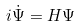<formula> <loc_0><loc_0><loc_500><loc_500>i \dot { \Psi } = H \Psi</formula> 